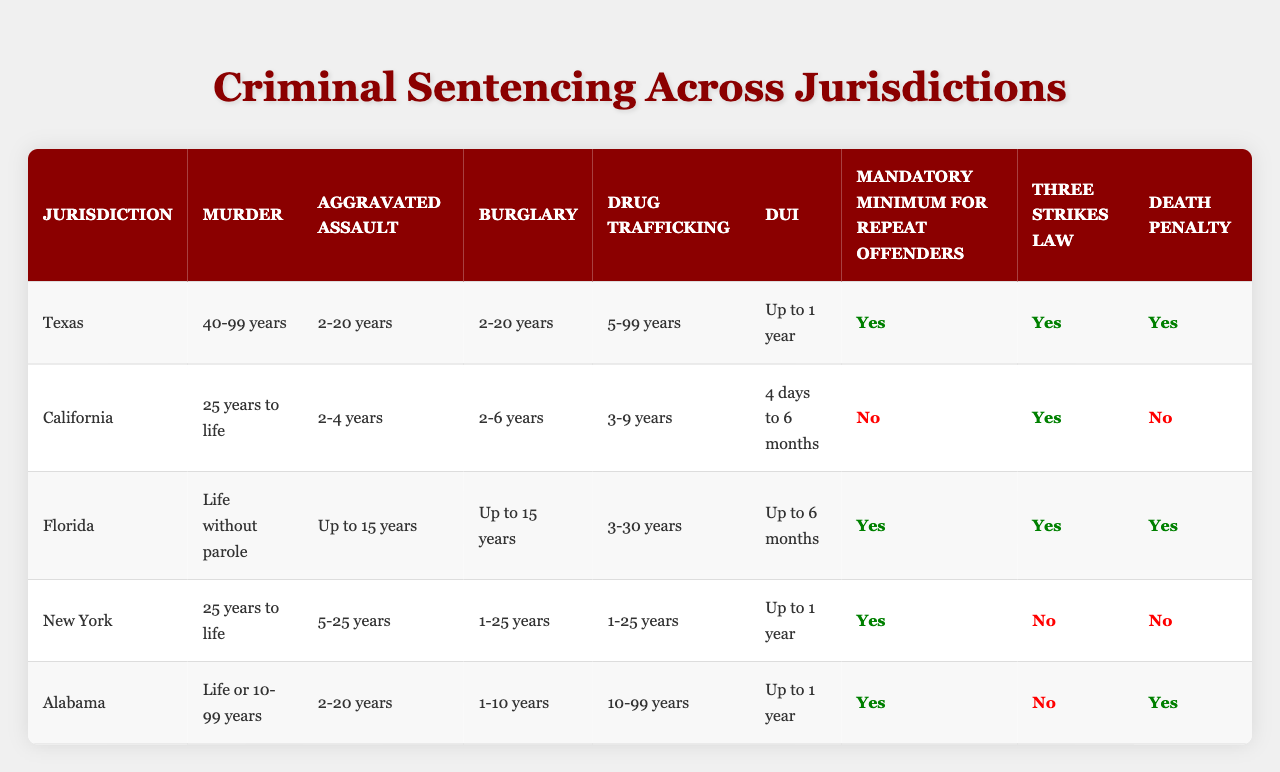What is the sentencing range for murder in California? Referring to the "Murder" column for California, the table shows "25 years to life" as the sentencing range.
Answer: 25 years to life Which jurisdiction has the most severe punishment for burglary? The "Burglary" column shows "1-25 years" for New York as the longest range, but we look at life sentences as the most severe. Only Florida has up to 15 years. Therefore, since "life" isn't in the range, New York's 1-25 years is highest in perception of severity.
Answer: New York Is there a Three Strikes Law in Florida? The "Three Strikes Law" column indicates "Yes" for Florida.
Answer: Yes Which jurisdictions impose a death penalty? The "Death Penalty" column shows that Texas, Florida, and Alabama impose the death penalty, while California and New York do not.
Answer: Texas, Florida, Alabama What is the average sentencing length for aggravated assault across the jurisdictions? For Aggravated Assault: Texas (11 years), California (3 years), Florida (7.5 years), New York (15 years), Alabama (11 years). Adding them up: (11 + 3 + 7.5 + 15 + 11) = 47.5 years. Dividing by 5 gives an average of 9.5 years.
Answer: 9.5 years Which jurisdiction has the longest sentencing length for drug trafficking? The "Drug Trafficking" column shows Texas with "5-99 years," which has the broadest range, indicating potentially the longest punishment.
Answer: Texas Is there a mandatory minimum for repeat offenders in Alabama? The "Mandatory Minimum for Repeat Offenders" column indicates "Yes" for Alabama.
Answer: Yes In which states is the three strikes law not enforced? From the "Three Strikes Law" column, New York and Alabama do not have this law enforced.
Answer: New York, Alabama What is the total number of jurisdictions that have a mandatory minimum for repeat offenders? From the "Mandatory Minimum for Repeat Offenders" column, Texas, Florida, New York, and Alabama have "Yes" responses, totaling 4 jurisdictions.
Answer: 4 Which jurisdiction has the shortest DUI sentencing? In the "DUI" column, Florida has "Up to 6 months," the shortest listed sentencing.
Answer: Florida What is the longest possible sentence for aggravated assault in New York? The "Aggravated Assault" column for New York states "5-25 years," with the longest possible sentence at 25 years.
Answer: 25 years 